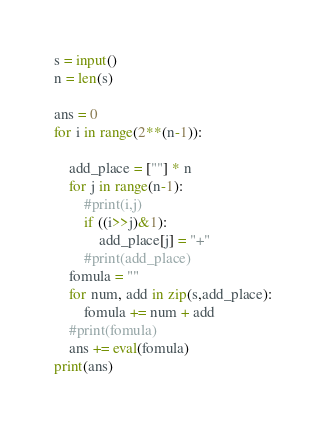Convert code to text. <code><loc_0><loc_0><loc_500><loc_500><_Python_>s = input()
n = len(s)

ans = 0
for i in range(2**(n-1)):
    
    add_place = [""] * n
    for j in range(n-1):
        #print(i,j)
        if ((i>>j)&1):
            add_place[j] = "+"
        #print(add_place)
    fomula = ""
    for num, add in zip(s,add_place):
        fomula += num + add
    #print(fomula)
    ans += eval(fomula)
print(ans)</code> 